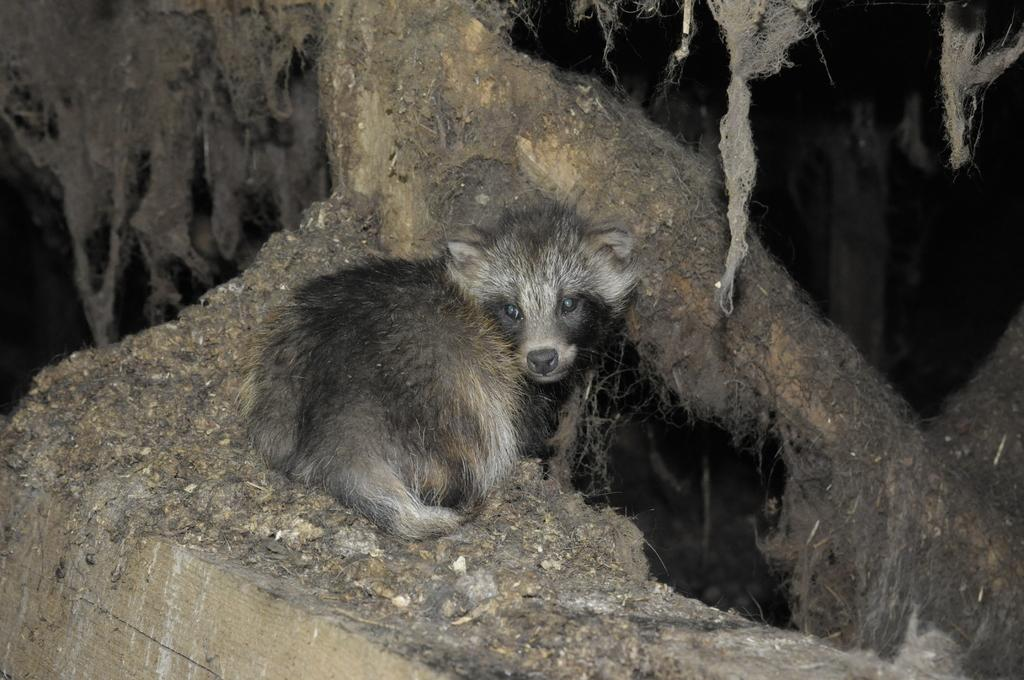What type of creature can be seen in the image? There is an animal in the image. Where is the animal located in the image? The animal is sitting on the ground. What type of honey is the animal collecting in the image? There is no honey present in the image, nor is there any indication that the animal is collecting honey. 